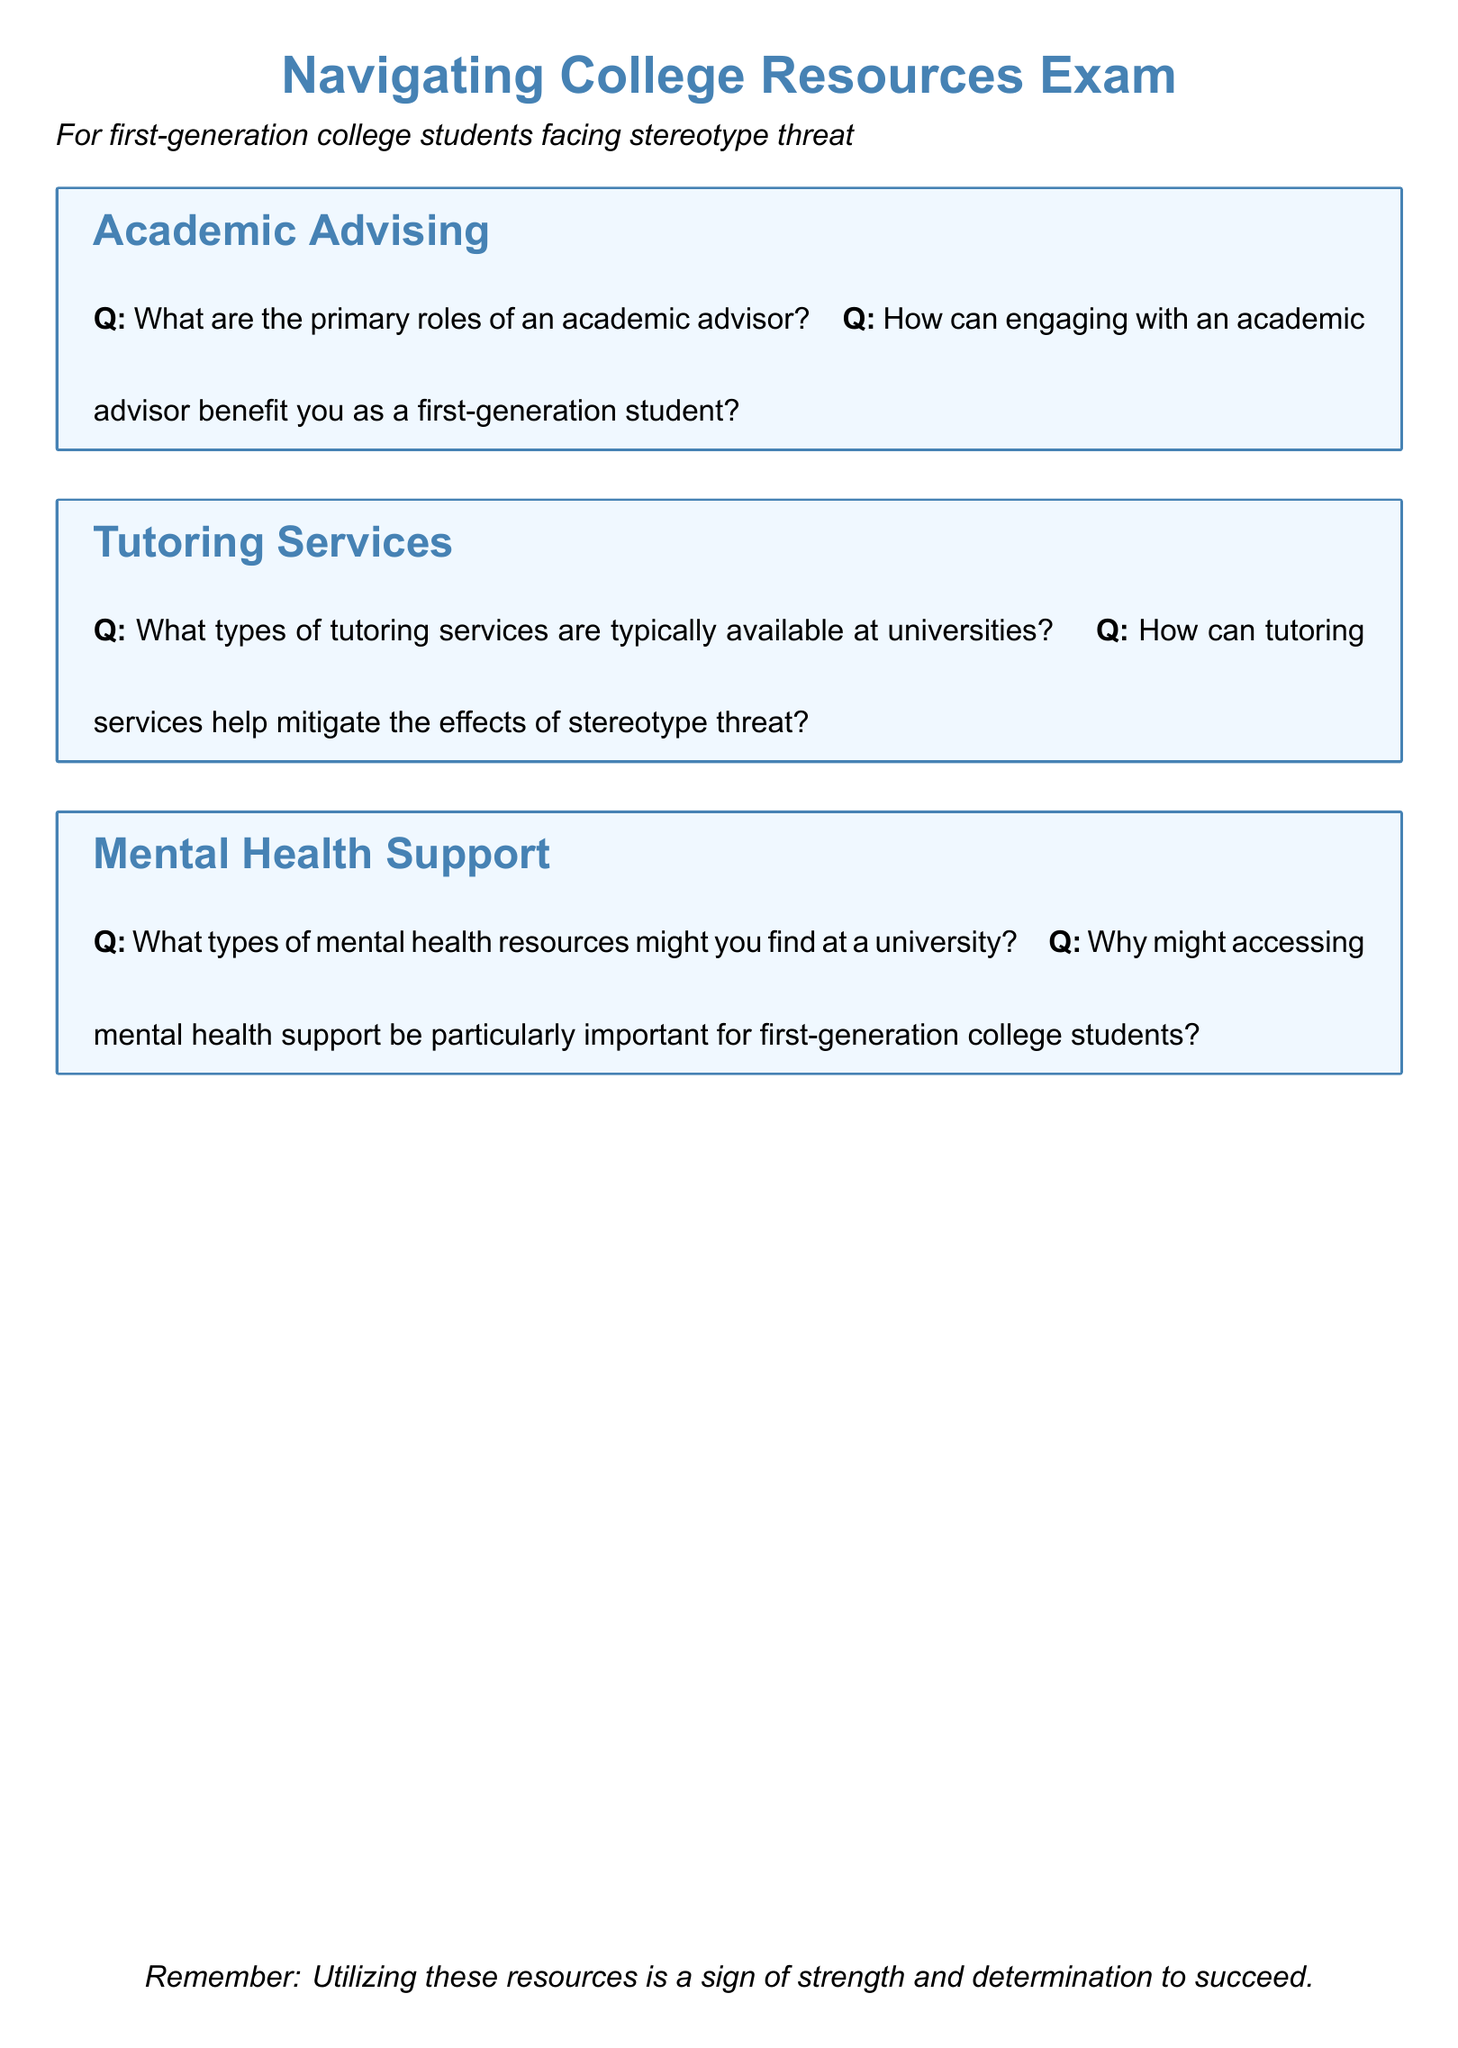What are the roles of an academic advisor? The roles of an academic advisor include guiding students on academic paths, helping with course selection, and providing support for educational goals.
Answer: Guiding, helping, providing support How can an academic advisor benefit first-generation students? Engaging with an academic advisor can provide first-generation students with tailored support and resources specific to their educational journey.
Answer: Tailored support and resources What tutoring services are typically available? Typically available tutoring services include subject-specific tutoring, study skills workshops, and peer tutoring sessions.
Answer: Subject-specific, study skills, peer tutoring How can tutoring services help with stereotype threat? Tutoring services can offer personalized support to boost confidence and academic performance, helping to mitigate the effects of stereotype threat.
Answer: Boost confidence, support What mental health resources are found at a university? Types of mental health resources at a university might include counseling services, support groups, and wellness workshops.
Answer: Counseling, support groups, workshops Why is mental health support important for first-generation students? Accessing mental health support is particularly important for first-generation college students due to the additional pressures and challenges they may face.
Answer: Additional pressures and challenges 